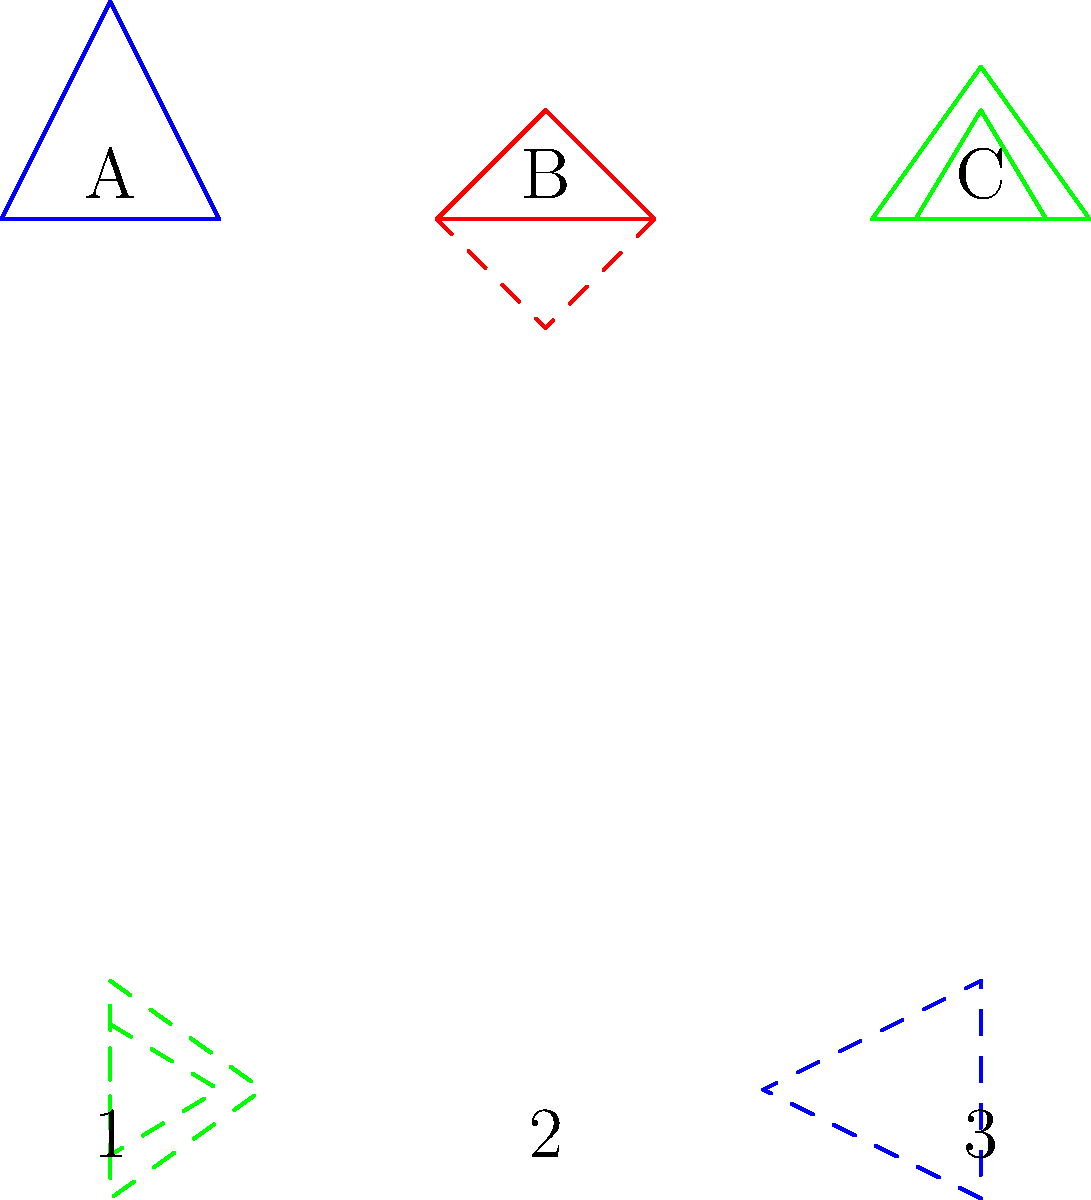Match the rotated architectural styles (1, 2, 3) with their original counterparts (A, B, C). Which combination correctly pairs the rotated shapes with their originals? To solve this problem, we need to mentally rotate each shape and compare it with the original styles. Let's go through this step-by-step:

1. Shape 1 (bottom left):
   - This shape is rotated 90 degrees clockwise from its original position.
   - After mental rotation, we can see it matches Shape A (Gothic style).

2. Shape 2 (bottom center):
   - This shape is rotated 180 degrees from its original position.
   - After mental rotation, we can see it matches Shape B (Romanesque style).

3. Shape 3 (bottom right):
   - This shape is rotated 270 degrees clockwise (or 90 degrees counterclockwise) from its original position.
   - After mental rotation, we can see it matches Shape C (Renaissance style).

Therefore, the correct pairing is:
- A matches with 1 (Gothic)
- B matches with 2 (Romanesque)
- C matches with 3 (Renaissance)
Answer: A1, B2, C3 